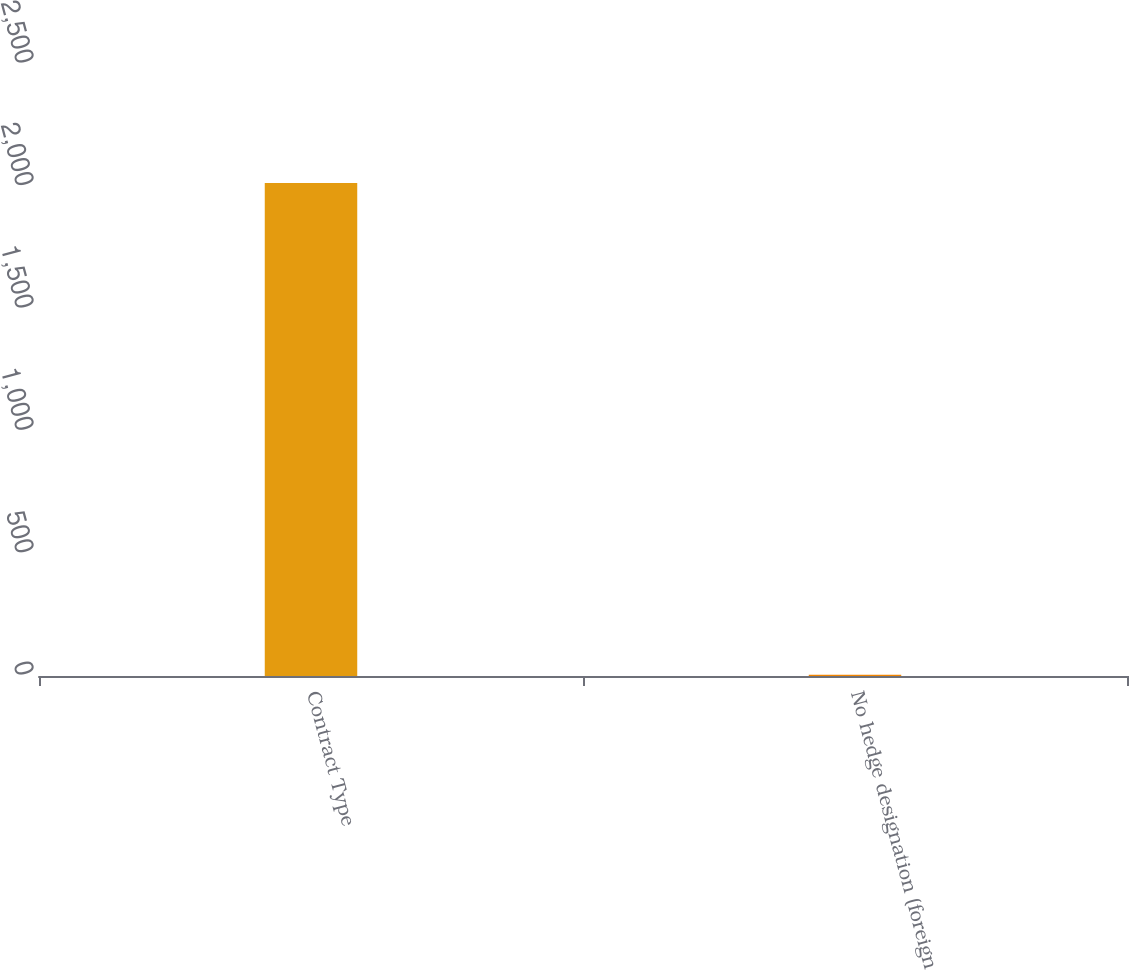Convert chart to OTSL. <chart><loc_0><loc_0><loc_500><loc_500><bar_chart><fcel>Contract Type<fcel>No hedge designation (foreign<nl><fcel>2014<fcel>5<nl></chart> 